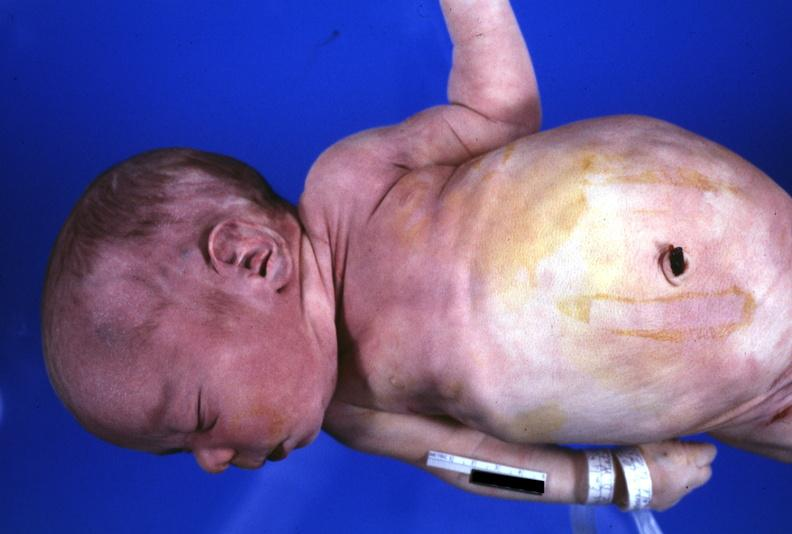s sets present?
Answer the question using a single word or phrase. No 